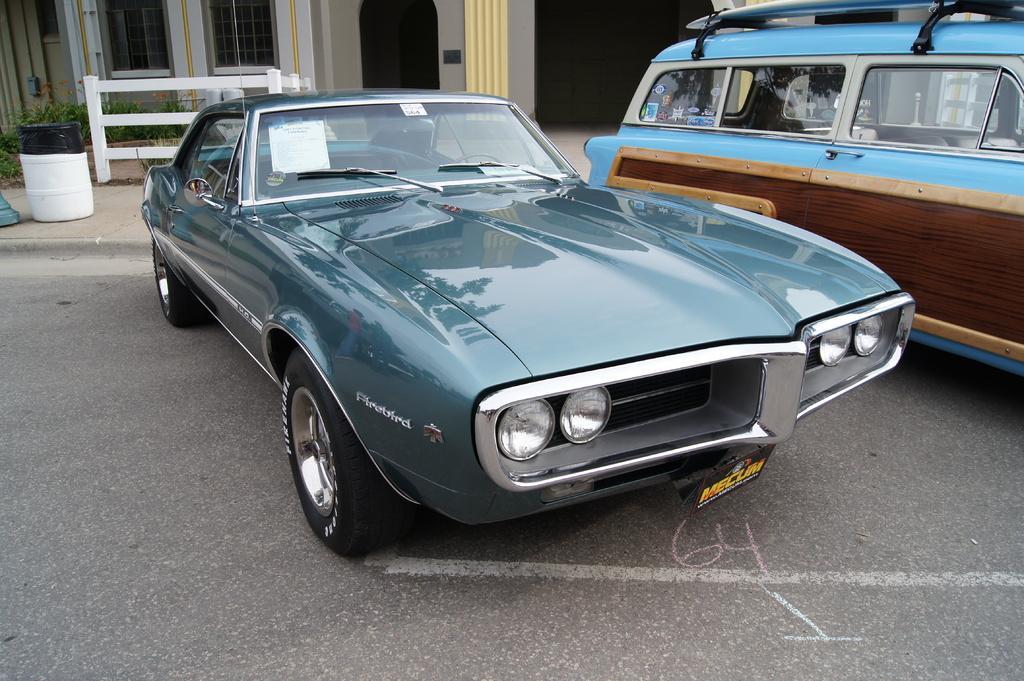Could you give a brief overview of what you see in this image? In this picture I can see there are two cars parked at right side and it has doors, windshield, wheels and there is another car at right side, there is a building in the backdrop, it has windows and there is a door. 